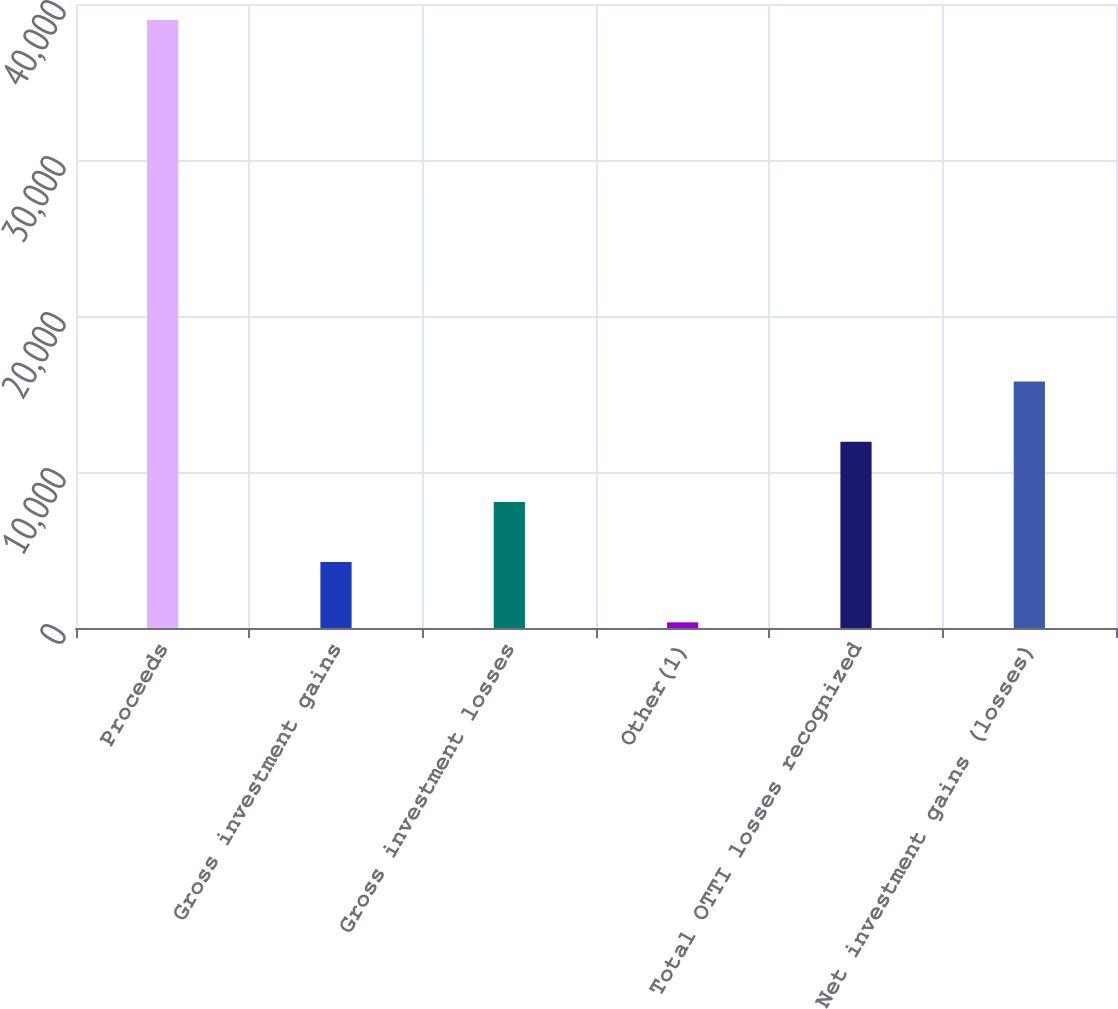Convert chart. <chart><loc_0><loc_0><loc_500><loc_500><bar_chart><fcel>Proceeds<fcel>Gross investment gains<fcel>Gross investment losses<fcel>Other(1)<fcel>Total OTTI losses recognized<fcel>Net investment gains (losses)<nl><fcel>38972<fcel>4223.9<fcel>8084.8<fcel>363<fcel>11945.7<fcel>15806.6<nl></chart> 